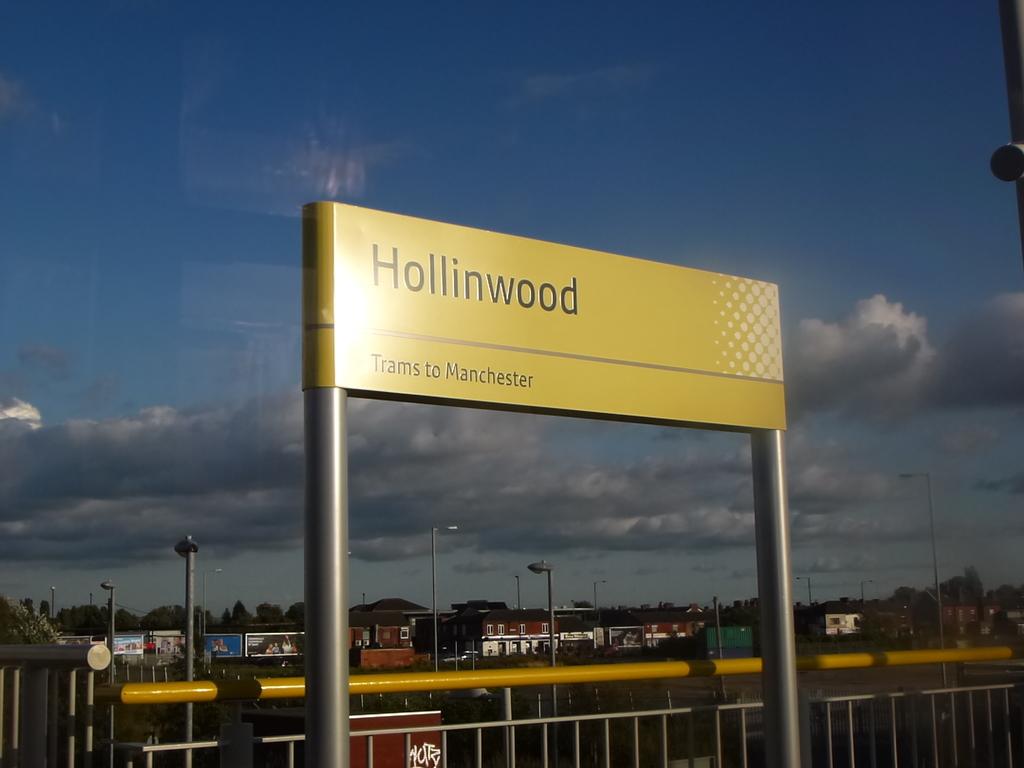Where does the trams go to?
Make the answer very short. Manchester. What does hollinwood represent?
Your answer should be very brief. Trams to manchester. 